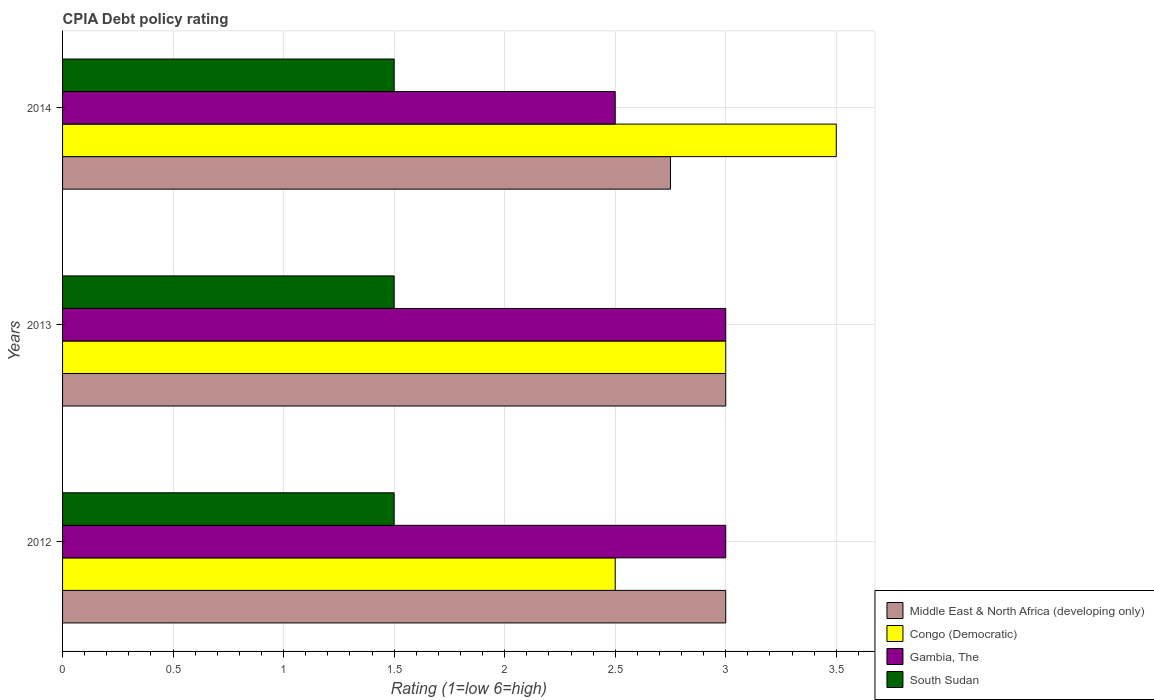Are the number of bars on each tick of the Y-axis equal?
Your response must be concise. Yes. How many bars are there on the 1st tick from the top?
Your answer should be compact. 4. What is the label of the 3rd group of bars from the top?
Your answer should be very brief. 2012. What is the CPIA rating in South Sudan in 2012?
Make the answer very short. 1.5. Across all years, what is the maximum CPIA rating in South Sudan?
Your answer should be very brief. 1.5. Across all years, what is the minimum CPIA rating in Middle East & North Africa (developing only)?
Make the answer very short. 2.75. What is the average CPIA rating in Middle East & North Africa (developing only) per year?
Keep it short and to the point. 2.92. In how many years, is the CPIA rating in Congo (Democratic) greater than 3.1 ?
Your answer should be compact. 1. Is the CPIA rating in South Sudan in 2013 less than that in 2014?
Offer a terse response. No. Is the difference between the CPIA rating in Gambia, The in 2012 and 2013 greater than the difference between the CPIA rating in Middle East & North Africa (developing only) in 2012 and 2013?
Give a very brief answer. No. What is the difference between the highest and the second highest CPIA rating in Middle East & North Africa (developing only)?
Your answer should be very brief. 0. What is the difference between the highest and the lowest CPIA rating in Congo (Democratic)?
Your response must be concise. 1. Is the sum of the CPIA rating in South Sudan in 2012 and 2013 greater than the maximum CPIA rating in Gambia, The across all years?
Give a very brief answer. No. What does the 2nd bar from the top in 2014 represents?
Provide a short and direct response. Gambia, The. What does the 4th bar from the bottom in 2012 represents?
Your response must be concise. South Sudan. How many bars are there?
Your answer should be very brief. 12. Are all the bars in the graph horizontal?
Offer a very short reply. Yes. How many years are there in the graph?
Your response must be concise. 3. Does the graph contain any zero values?
Provide a succinct answer. No. What is the title of the graph?
Ensure brevity in your answer.  CPIA Debt policy rating. What is the label or title of the X-axis?
Provide a short and direct response. Rating (1=low 6=high). What is the label or title of the Y-axis?
Your response must be concise. Years. What is the Rating (1=low 6=high) in Middle East & North Africa (developing only) in 2012?
Offer a very short reply. 3. What is the Rating (1=low 6=high) in Congo (Democratic) in 2012?
Make the answer very short. 2.5. What is the Rating (1=low 6=high) of South Sudan in 2012?
Give a very brief answer. 1.5. What is the Rating (1=low 6=high) in Middle East & North Africa (developing only) in 2013?
Give a very brief answer. 3. What is the Rating (1=low 6=high) in Congo (Democratic) in 2013?
Offer a very short reply. 3. What is the Rating (1=low 6=high) of Gambia, The in 2013?
Make the answer very short. 3. What is the Rating (1=low 6=high) in Middle East & North Africa (developing only) in 2014?
Ensure brevity in your answer.  2.75. What is the Rating (1=low 6=high) of Gambia, The in 2014?
Provide a short and direct response. 2.5. Across all years, what is the maximum Rating (1=low 6=high) in Congo (Democratic)?
Keep it short and to the point. 3.5. Across all years, what is the maximum Rating (1=low 6=high) in Gambia, The?
Offer a very short reply. 3. Across all years, what is the minimum Rating (1=low 6=high) in Middle East & North Africa (developing only)?
Give a very brief answer. 2.75. Across all years, what is the minimum Rating (1=low 6=high) of Congo (Democratic)?
Offer a terse response. 2.5. Across all years, what is the minimum Rating (1=low 6=high) of Gambia, The?
Offer a very short reply. 2.5. Across all years, what is the minimum Rating (1=low 6=high) of South Sudan?
Ensure brevity in your answer.  1.5. What is the total Rating (1=low 6=high) in Middle East & North Africa (developing only) in the graph?
Give a very brief answer. 8.75. What is the total Rating (1=low 6=high) of South Sudan in the graph?
Give a very brief answer. 4.5. What is the difference between the Rating (1=low 6=high) of Middle East & North Africa (developing only) in 2012 and that in 2013?
Keep it short and to the point. 0. What is the difference between the Rating (1=low 6=high) in Middle East & North Africa (developing only) in 2012 and that in 2014?
Your answer should be compact. 0.25. What is the difference between the Rating (1=low 6=high) in Gambia, The in 2012 and that in 2014?
Offer a terse response. 0.5. What is the difference between the Rating (1=low 6=high) in Middle East & North Africa (developing only) in 2013 and that in 2014?
Offer a very short reply. 0.25. What is the difference between the Rating (1=low 6=high) of Congo (Democratic) in 2013 and that in 2014?
Keep it short and to the point. -0.5. What is the difference between the Rating (1=low 6=high) of Gambia, The in 2013 and that in 2014?
Provide a short and direct response. 0.5. What is the difference between the Rating (1=low 6=high) in South Sudan in 2013 and that in 2014?
Your answer should be compact. 0. What is the difference between the Rating (1=low 6=high) in Middle East & North Africa (developing only) in 2012 and the Rating (1=low 6=high) in Gambia, The in 2013?
Your response must be concise. 0. What is the difference between the Rating (1=low 6=high) of Middle East & North Africa (developing only) in 2012 and the Rating (1=low 6=high) of South Sudan in 2013?
Offer a terse response. 1.5. What is the difference between the Rating (1=low 6=high) in Congo (Democratic) in 2012 and the Rating (1=low 6=high) in South Sudan in 2013?
Offer a terse response. 1. What is the difference between the Rating (1=low 6=high) in Gambia, The in 2012 and the Rating (1=low 6=high) in South Sudan in 2013?
Provide a short and direct response. 1.5. What is the difference between the Rating (1=low 6=high) of Middle East & North Africa (developing only) in 2012 and the Rating (1=low 6=high) of Gambia, The in 2014?
Your answer should be very brief. 0.5. What is the difference between the Rating (1=low 6=high) of Middle East & North Africa (developing only) in 2012 and the Rating (1=low 6=high) of South Sudan in 2014?
Offer a terse response. 1.5. What is the difference between the Rating (1=low 6=high) of Congo (Democratic) in 2012 and the Rating (1=low 6=high) of Gambia, The in 2014?
Ensure brevity in your answer.  0. What is the difference between the Rating (1=low 6=high) of Middle East & North Africa (developing only) in 2013 and the Rating (1=low 6=high) of Congo (Democratic) in 2014?
Ensure brevity in your answer.  -0.5. What is the difference between the Rating (1=low 6=high) of Middle East & North Africa (developing only) in 2013 and the Rating (1=low 6=high) of South Sudan in 2014?
Your answer should be compact. 1.5. What is the difference between the Rating (1=low 6=high) of Congo (Democratic) in 2013 and the Rating (1=low 6=high) of South Sudan in 2014?
Offer a very short reply. 1.5. What is the average Rating (1=low 6=high) in Middle East & North Africa (developing only) per year?
Offer a very short reply. 2.92. What is the average Rating (1=low 6=high) of Gambia, The per year?
Make the answer very short. 2.83. In the year 2012, what is the difference between the Rating (1=low 6=high) in Middle East & North Africa (developing only) and Rating (1=low 6=high) in Congo (Democratic)?
Give a very brief answer. 0.5. In the year 2012, what is the difference between the Rating (1=low 6=high) in Middle East & North Africa (developing only) and Rating (1=low 6=high) in South Sudan?
Provide a succinct answer. 1.5. In the year 2012, what is the difference between the Rating (1=low 6=high) in Congo (Democratic) and Rating (1=low 6=high) in Gambia, The?
Ensure brevity in your answer.  -0.5. In the year 2012, what is the difference between the Rating (1=low 6=high) in Congo (Democratic) and Rating (1=low 6=high) in South Sudan?
Provide a succinct answer. 1. In the year 2013, what is the difference between the Rating (1=low 6=high) in Middle East & North Africa (developing only) and Rating (1=low 6=high) in Gambia, The?
Your response must be concise. 0. In the year 2013, what is the difference between the Rating (1=low 6=high) of Congo (Democratic) and Rating (1=low 6=high) of South Sudan?
Your answer should be compact. 1.5. In the year 2013, what is the difference between the Rating (1=low 6=high) of Gambia, The and Rating (1=low 6=high) of South Sudan?
Ensure brevity in your answer.  1.5. In the year 2014, what is the difference between the Rating (1=low 6=high) of Middle East & North Africa (developing only) and Rating (1=low 6=high) of Congo (Democratic)?
Offer a terse response. -0.75. In the year 2014, what is the difference between the Rating (1=low 6=high) of Congo (Democratic) and Rating (1=low 6=high) of Gambia, The?
Offer a very short reply. 1. In the year 2014, what is the difference between the Rating (1=low 6=high) of Gambia, The and Rating (1=low 6=high) of South Sudan?
Offer a very short reply. 1. What is the ratio of the Rating (1=low 6=high) in Congo (Democratic) in 2012 to that in 2013?
Offer a very short reply. 0.83. What is the ratio of the Rating (1=low 6=high) in Middle East & North Africa (developing only) in 2012 to that in 2014?
Make the answer very short. 1.09. What is the ratio of the Rating (1=low 6=high) in South Sudan in 2012 to that in 2014?
Offer a very short reply. 1. What is the ratio of the Rating (1=low 6=high) of Middle East & North Africa (developing only) in 2013 to that in 2014?
Your answer should be compact. 1.09. What is the ratio of the Rating (1=low 6=high) of Congo (Democratic) in 2013 to that in 2014?
Provide a succinct answer. 0.86. What is the ratio of the Rating (1=low 6=high) in South Sudan in 2013 to that in 2014?
Offer a terse response. 1. What is the difference between the highest and the second highest Rating (1=low 6=high) of Congo (Democratic)?
Your answer should be compact. 0.5. What is the difference between the highest and the second highest Rating (1=low 6=high) of Gambia, The?
Keep it short and to the point. 0. What is the difference between the highest and the second highest Rating (1=low 6=high) of South Sudan?
Give a very brief answer. 0. What is the difference between the highest and the lowest Rating (1=low 6=high) in Congo (Democratic)?
Give a very brief answer. 1. What is the difference between the highest and the lowest Rating (1=low 6=high) in South Sudan?
Make the answer very short. 0. 